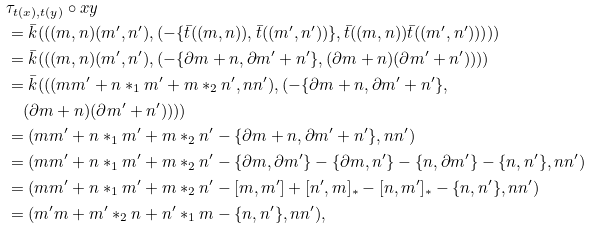<formula> <loc_0><loc_0><loc_500><loc_500>& \tau _ { t ( x ) , t ( y ) } \circ x y \\ & = \bar { k } ( ( ( m , n ) ( m ^ { \prime } , n ^ { \prime } ) , ( - \{ \bar { t } ( ( m , n ) ) , \bar { t } ( ( m ^ { \prime } , n ^ { \prime } ) ) \} , \bar { t } ( ( m , n ) ) \bar { t } ( ( m ^ { \prime } , n ^ { \prime } ) ) ) ) ) \\ & = \bar { k } ( ( ( m , n ) ( m ^ { \prime } , n ^ { \prime } ) , ( - \{ \partial m + n , \partial m ^ { \prime } + n ^ { \prime } \} , ( \partial m + n ) ( \partial m ^ { \prime } + n ^ { \prime } ) ) ) ) \\ & = \bar { k } ( ( ( m m ^ { \prime } + n * _ { 1 } m ^ { \prime } + m * _ { 2 } n ^ { \prime } , n n ^ { \prime } ) , ( - \{ \partial m + n , \partial m ^ { \prime } + n ^ { \prime } \} , \\ & \quad ( \partial m + n ) ( \partial m ^ { \prime } + n ^ { \prime } ) ) ) ) \\ & = ( m m ^ { \prime } + n * _ { 1 } m ^ { \prime } + m * _ { 2 } n ^ { \prime } - \{ \partial m + n , \partial m ^ { \prime } + n ^ { \prime } \} , n n ^ { \prime } ) \\ & = ( m m ^ { \prime } + n * _ { 1 } m ^ { \prime } + m * _ { 2 } n ^ { \prime } - \{ \partial m , \partial m ^ { \prime } \} - \{ \partial m , n ^ { \prime } \} - \{ n , \partial m ^ { \prime } \} - \{ n , n ^ { \prime } \} , n n ^ { \prime } ) \\ & = ( m m ^ { \prime } + n * _ { 1 } m ^ { \prime } + m * _ { 2 } n ^ { \prime } - [ m , m ^ { \prime } ] + [ n ^ { \prime } , m ] _ { * } - [ n , m ^ { \prime } ] _ { * } - \{ n , n ^ { \prime } \} , n n ^ { \prime } ) \\ & = ( m ^ { \prime } m + m ^ { \prime } * _ { 2 } n + n ^ { \prime } * _ { 1 } m - \{ n , n ^ { \prime } \} , n n ^ { \prime } ) ,</formula> 